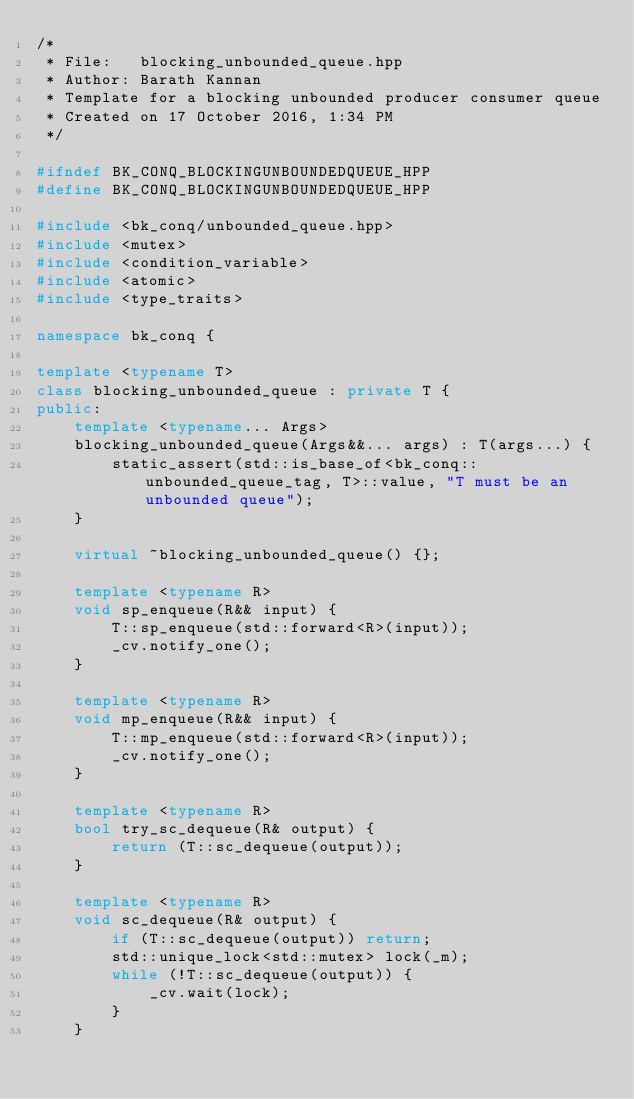<code> <loc_0><loc_0><loc_500><loc_500><_C++_>/*
 * File:   blocking_unbounded_queue.hpp
 * Author: Barath Kannan
 * Template for a blocking unbounded producer consumer queue
 * Created on 17 October 2016, 1:34 PM
 */

#ifndef BK_CONQ_BLOCKINGUNBOUNDEDQUEUE_HPP
#define BK_CONQ_BLOCKINGUNBOUNDEDQUEUE_HPP

#include <bk_conq/unbounded_queue.hpp>
#include <mutex>
#include <condition_variable>
#include <atomic>
#include <type_traits>

namespace bk_conq {

template <typename T>
class blocking_unbounded_queue : private T {
public:
    template <typename... Args>
    blocking_unbounded_queue(Args&&... args) : T(args...) {
        static_assert(std::is_base_of<bk_conq::unbounded_queue_tag, T>::value, "T must be an unbounded queue");
    }

    virtual ~blocking_unbounded_queue() {};

    template <typename R>
    void sp_enqueue(R&& input) {
        T::sp_enqueue(std::forward<R>(input));
        _cv.notify_one();
    }

    template <typename R>
    void mp_enqueue(R&& input) {
        T::mp_enqueue(std::forward<R>(input));
        _cv.notify_one();
    }

    template <typename R>
    bool try_sc_dequeue(R& output) {
        return (T::sc_dequeue(output));
    }

    template <typename R>
    void sc_dequeue(R& output) {
        if (T::sc_dequeue(output)) return;
        std::unique_lock<std::mutex> lock(_m);
        while (!T::sc_dequeue(output)) {
            _cv.wait(lock);
        }
    }
</code> 